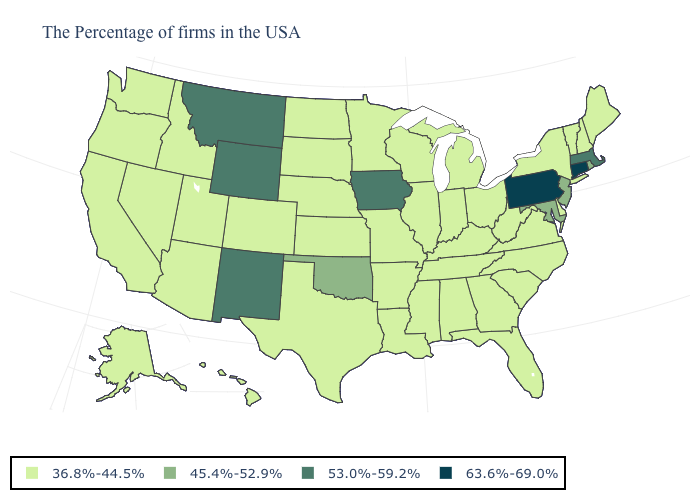Name the states that have a value in the range 36.8%-44.5%?
Be succinct. Maine, New Hampshire, Vermont, New York, Delaware, Virginia, North Carolina, South Carolina, West Virginia, Ohio, Florida, Georgia, Michigan, Kentucky, Indiana, Alabama, Tennessee, Wisconsin, Illinois, Mississippi, Louisiana, Missouri, Arkansas, Minnesota, Kansas, Nebraska, Texas, South Dakota, North Dakota, Colorado, Utah, Arizona, Idaho, Nevada, California, Washington, Oregon, Alaska, Hawaii. What is the value of Ohio?
Be succinct. 36.8%-44.5%. Which states hav the highest value in the Northeast?
Be succinct. Connecticut, Pennsylvania. Does New Mexico have the highest value in the West?
Write a very short answer. Yes. What is the highest value in states that border South Dakota?
Keep it brief. 53.0%-59.2%. What is the lowest value in states that border South Dakota?
Write a very short answer. 36.8%-44.5%. Does Connecticut have the lowest value in the Northeast?
Concise answer only. No. What is the lowest value in the USA?
Be succinct. 36.8%-44.5%. How many symbols are there in the legend?
Answer briefly. 4. Which states hav the highest value in the MidWest?
Write a very short answer. Iowa. Among the states that border Delaware , does New Jersey have the lowest value?
Short answer required. Yes. Name the states that have a value in the range 53.0%-59.2%?
Keep it brief. Massachusetts, Iowa, Wyoming, New Mexico, Montana. Does Maryland have the highest value in the South?
Short answer required. Yes. Does Wyoming have the lowest value in the USA?
Answer briefly. No. What is the value of Ohio?
Quick response, please. 36.8%-44.5%. 